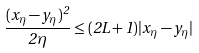<formula> <loc_0><loc_0><loc_500><loc_500>\frac { ( x _ { \eta } - y _ { \eta } ) ^ { 2 } } { 2 \eta } \leq ( 2 L + 1 ) | x _ { \eta } - y _ { \eta } |</formula> 